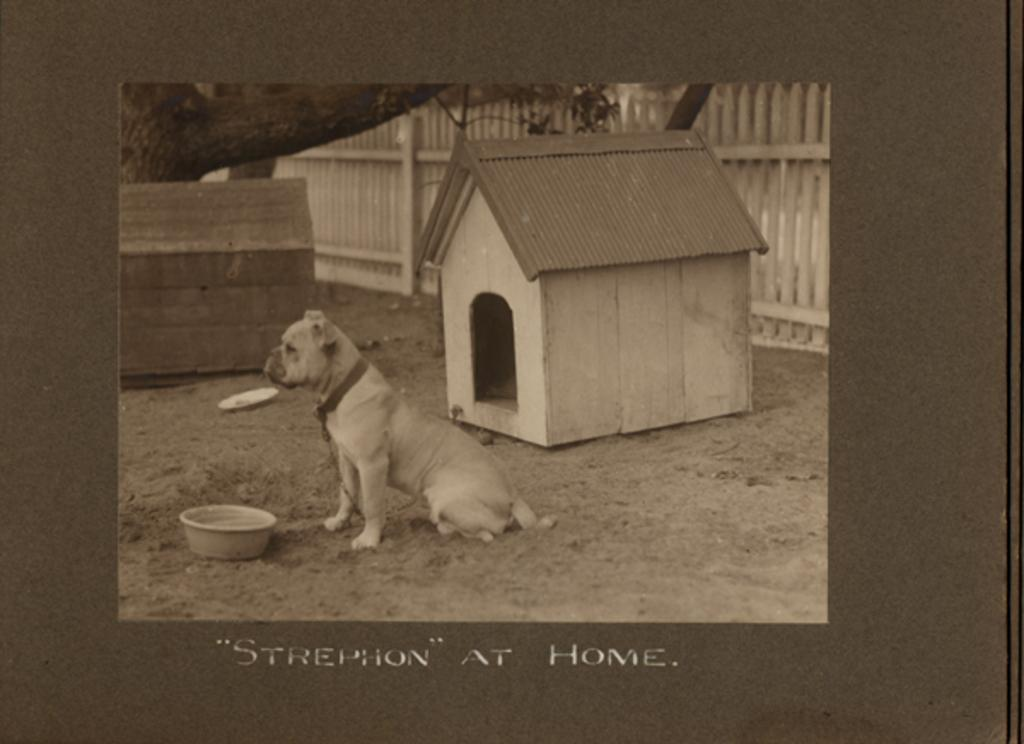What type of animal is in the image? There is a dog in the image. What is in front of the dog? There is a bowl in front of the dog. What structure is present for the dog to use as shelter? There is a dog house in the image. What type of barrier can be seen in the image? There is a wooden fence in the image. What object is made of wood and has a rectangular shape? There is a wooden box in the image. What natural element is present in the image? There is a tree branch in the image. What type of writing or symbols can be seen in the image? There is text visible in the image. What type of seat is the girl sitting on in the image? There is no girl present in the image, so there is no seat for her to sit on. 